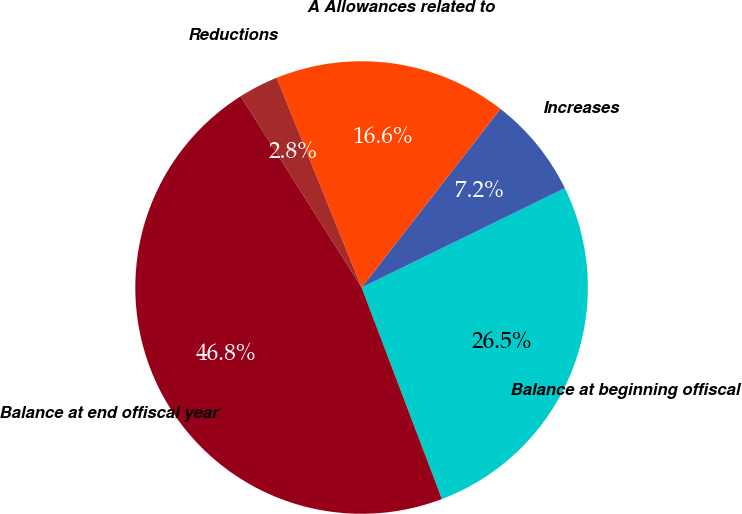<chart> <loc_0><loc_0><loc_500><loc_500><pie_chart><fcel>Balance at beginning offiscal<fcel>Increases<fcel>A Allowances related to<fcel>Reductions<fcel>Balance at end offiscal year<nl><fcel>26.46%<fcel>7.25%<fcel>16.64%<fcel>2.85%<fcel>46.8%<nl></chart> 